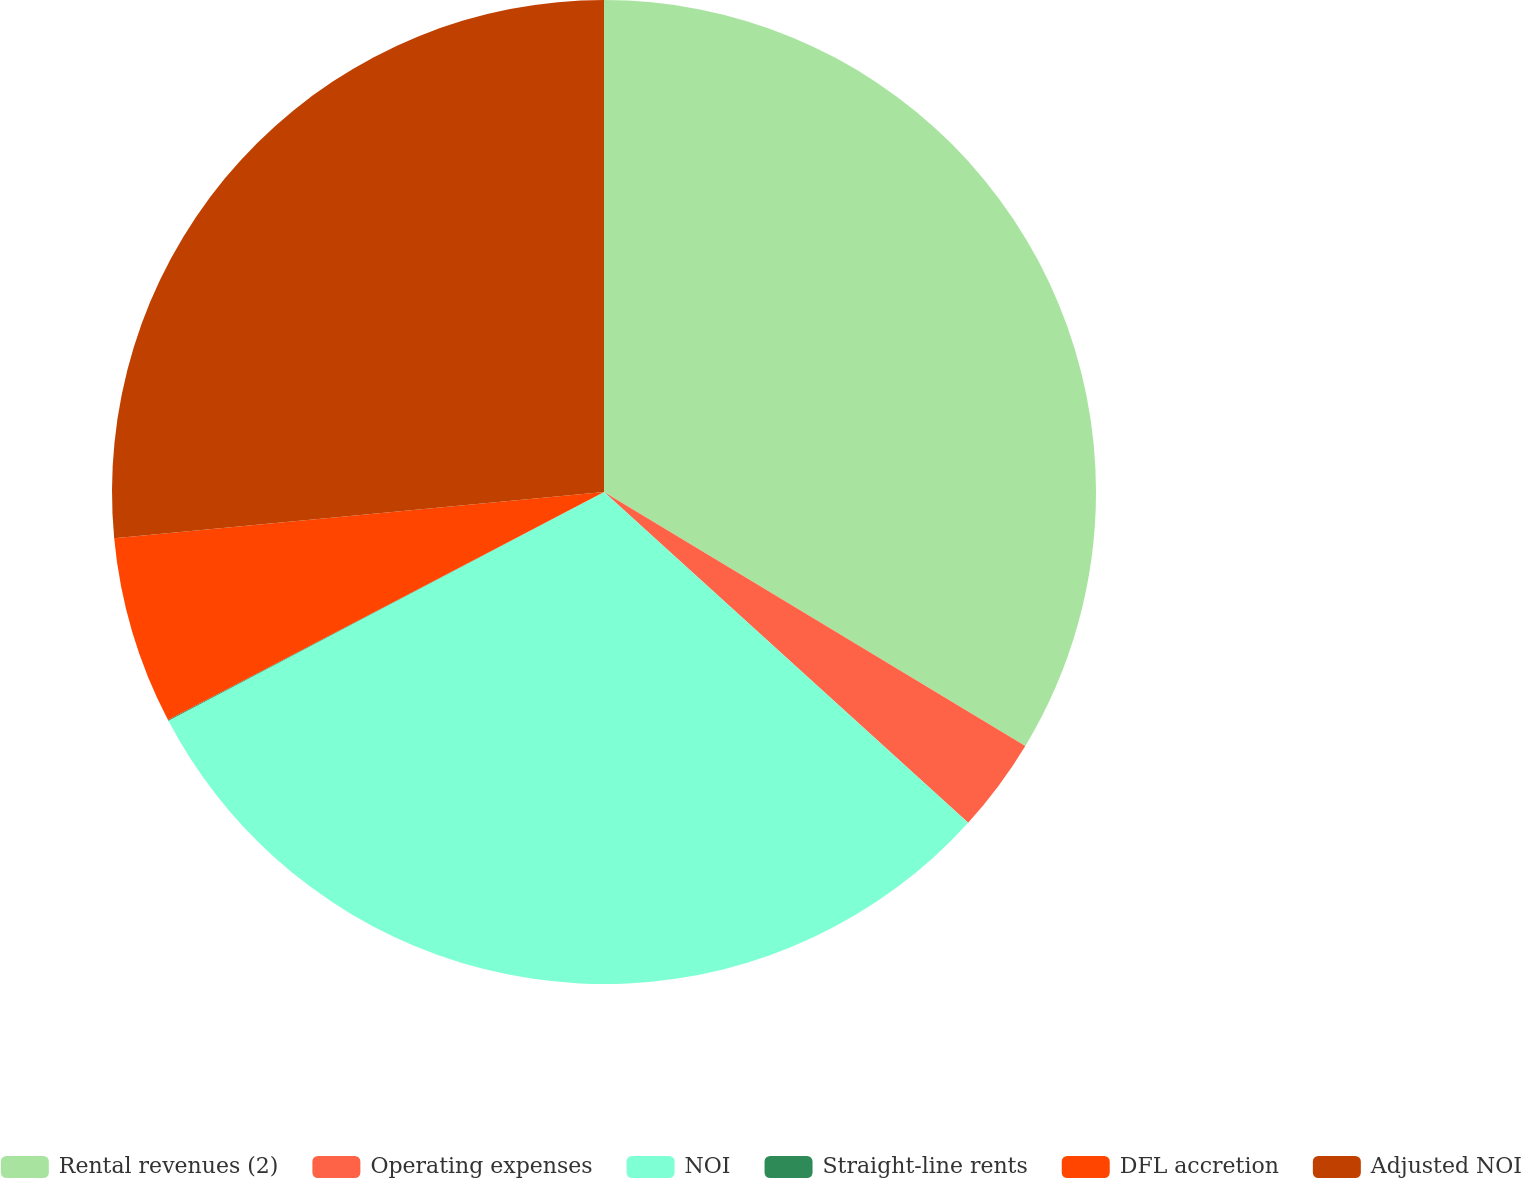<chart> <loc_0><loc_0><loc_500><loc_500><pie_chart><fcel>Rental revenues (2)<fcel>Operating expenses<fcel>NOI<fcel>Straight-line rents<fcel>DFL accretion<fcel>Adjusted NOI<nl><fcel>33.64%<fcel>3.1%<fcel>30.57%<fcel>0.03%<fcel>6.17%<fcel>26.5%<nl></chart> 